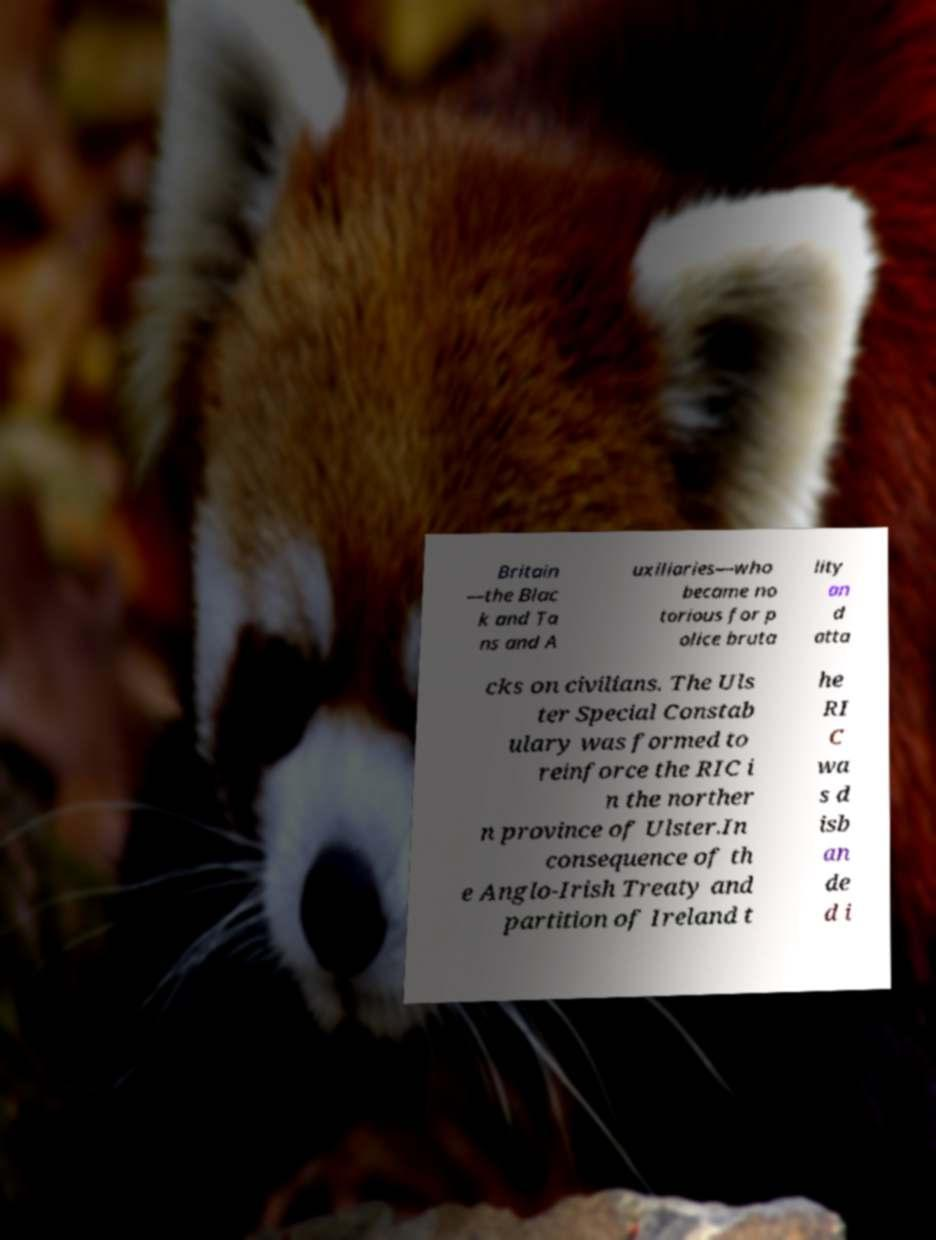For documentation purposes, I need the text within this image transcribed. Could you provide that? Britain —the Blac k and Ta ns and A uxiliaries—who became no torious for p olice bruta lity an d atta cks on civilians. The Uls ter Special Constab ulary was formed to reinforce the RIC i n the norther n province of Ulster.In consequence of th e Anglo-Irish Treaty and partition of Ireland t he RI C wa s d isb an de d i 